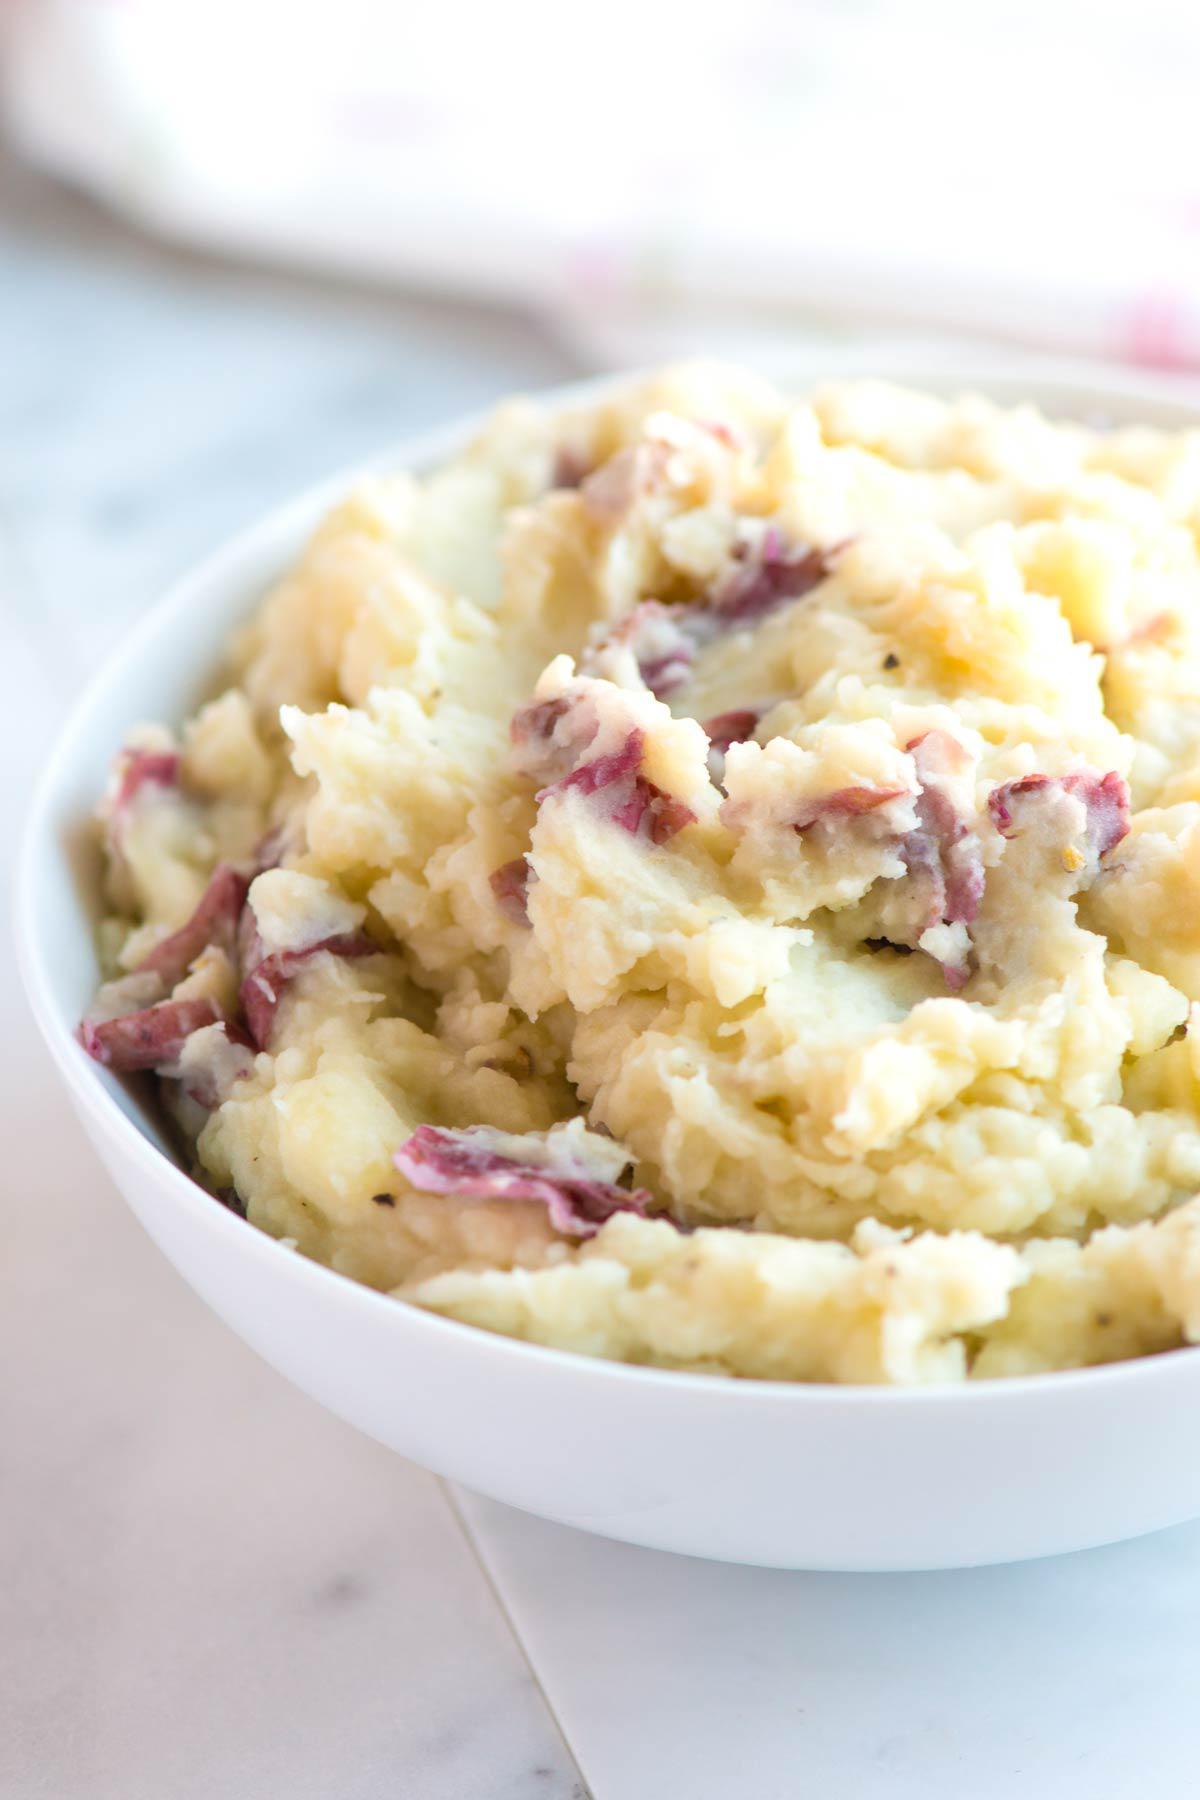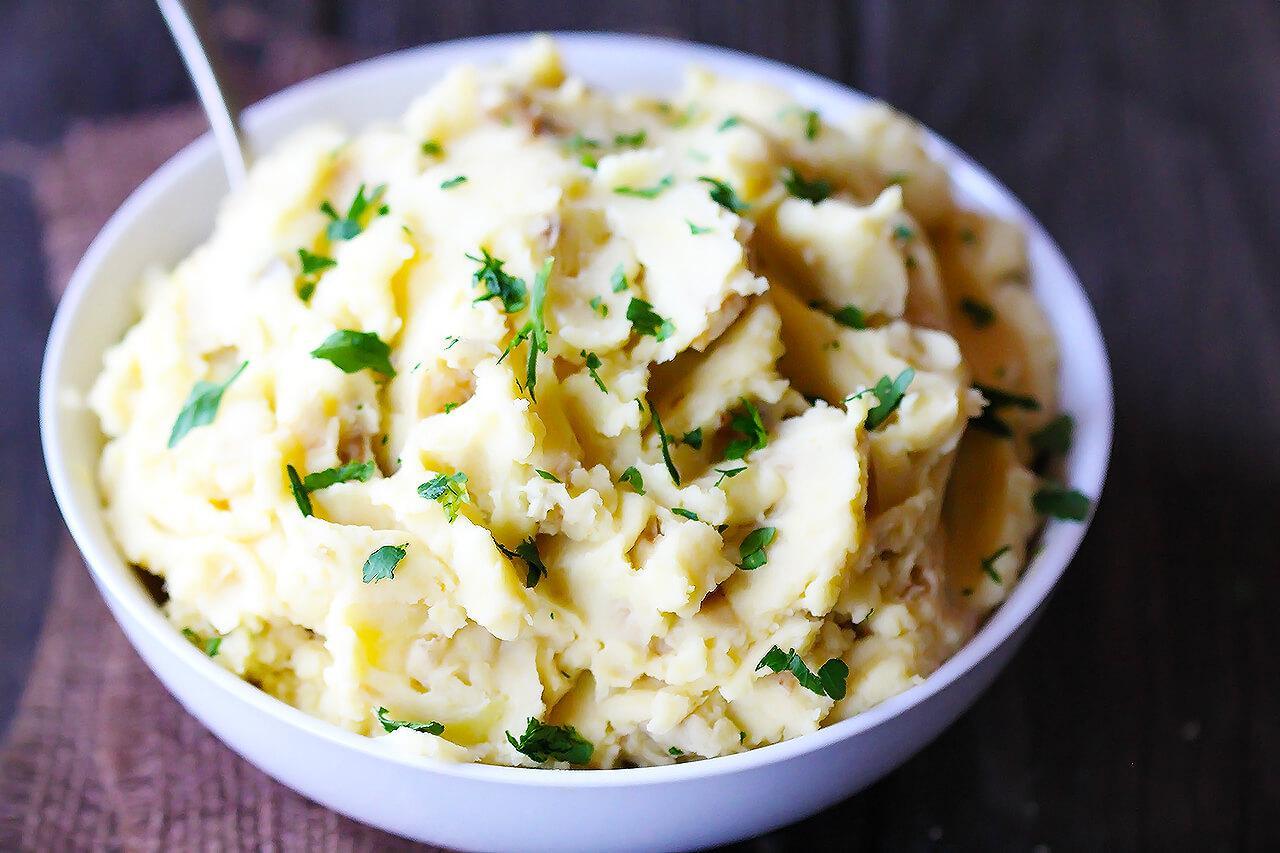The first image is the image on the left, the second image is the image on the right. Evaluate the accuracy of this statement regarding the images: "There is a bowl of mashed potatoes with a spoon in it". Is it true? Answer yes or no. Yes. 